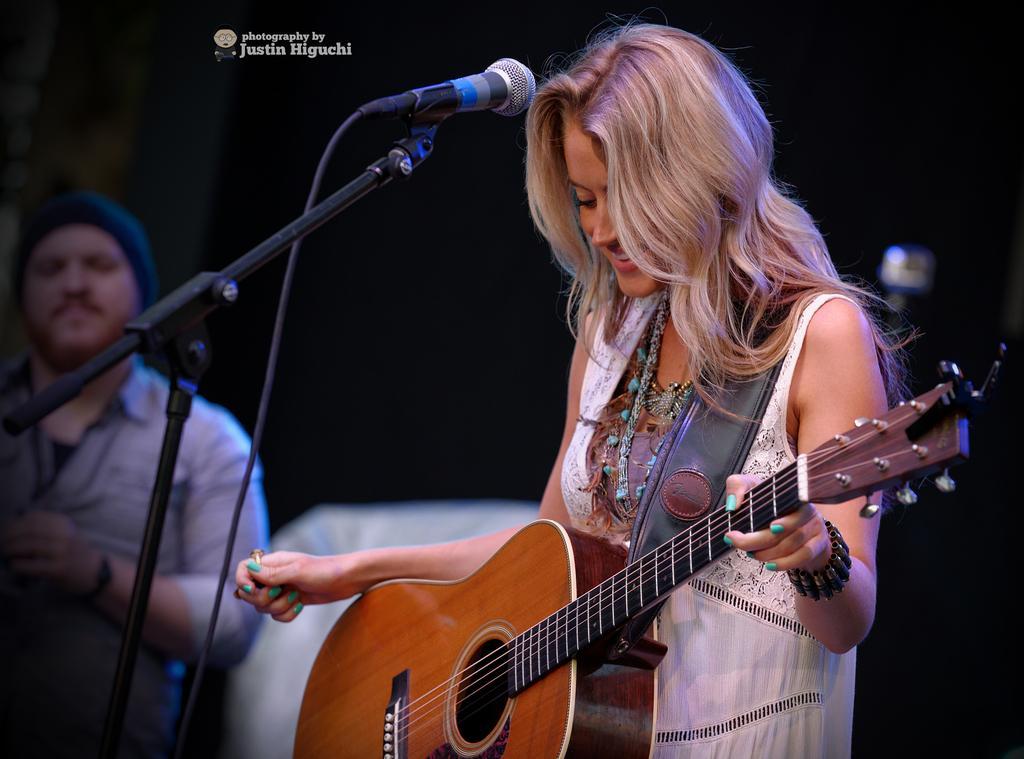Please provide a concise description of this image. A woman is standing and also playing the guitar. There is a microphone at the left and a man is standing at the left side. 